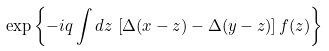Convert formula to latex. <formula><loc_0><loc_0><loc_500><loc_500>\exp \left \{ - i q \int d z \, \left [ \Delta ( x - z ) - \Delta ( y - z ) \right ] f ( z ) \right \}</formula> 